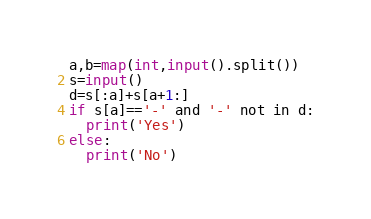<code> <loc_0><loc_0><loc_500><loc_500><_Python_>a,b=map(int,input().split())
s=input()
d=s[:a]+s[a+1:]
if s[a]=='-' and '-' not in d:
  print('Yes')
else:
  print('No')</code> 